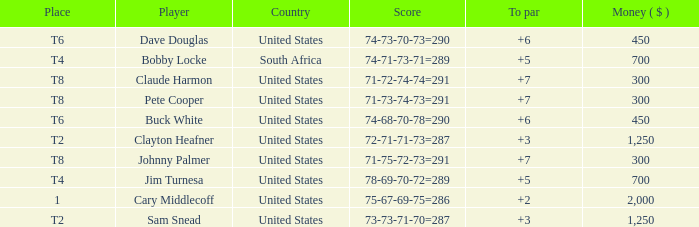What is Claude Harmon's Place? T8. 